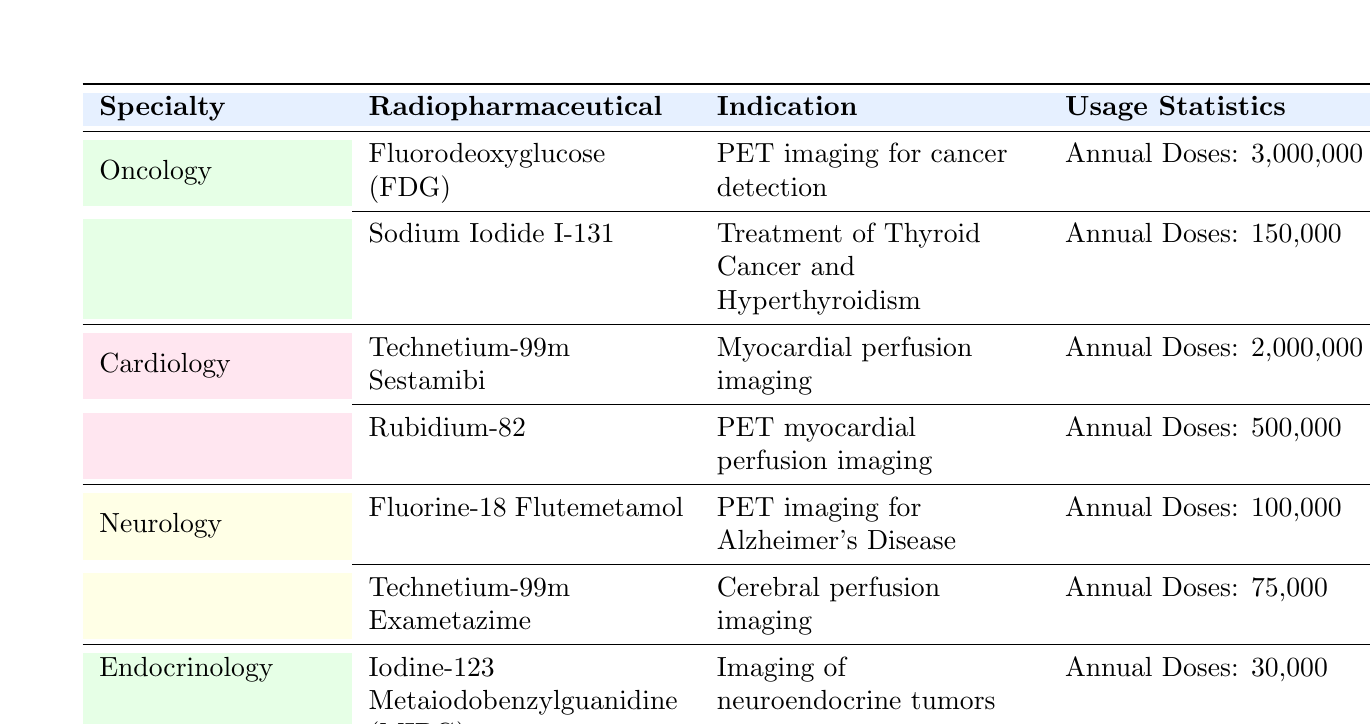What is the annual dose administered for Fluorodeoxyglucose (FDG)? According to the table, the annual doses administered for Fluorodeoxyglucose (FDG) is listed as 3,000,000.
Answer: 3,000,000 What is the main indication for Sodium Iodide I-131? The table states that the main indication for Sodium Iodide I-131 is the treatment of Thyroid Cancer and Hyperthyroidism.
Answer: Treatment of Thyroid Cancer and Hyperthyroidism How many annual doses are administered for Technetium-99m Sestamibi? The table shows that Technetium-99m Sestamibi has 2,000,000 annual doses administered.
Answer: 2,000,000 Which specialty has the lowest annual dose of radiopharmaceuticals administered? From the table, Endocrinology has the lowest annual dose of 30,000, compared to the other specialties with higher values.
Answer: Endocrinology What is the total annual dose administered for all radiation pharmaceuticals listed in Oncology? In Oncology, Fluorodeoxyglucose has 3,000,000 doses and Sodium Iodide I-131 has 150,000 doses. Adding these gives 3,000,000 + 150,000 = 3,150,000.
Answer: 3,150,000 Is it true that Fluorine-18 Flutemetamol is used for imaging in Coronary Artery Disease? The table indicates that Fluorine-18 Flutemetamol has an indication for PET imaging for Alzheimer's Disease, not for Coronary Artery Disease. Thus, the statement is false.
Answer: No How many more doses are administered for Technetium-99m Sestamibi than for Technetium-99m Exametazime? The annual doses for Technetium-99m Sestamibi is 2,000,000 and for Technetium-99m Exametazime is 75,000. The difference is 2,000,000 - 75,000 = 1,925,000.
Answer: 1,925,000 Which common condition is associated with the highest annual doses among the radiopharmaceuticals? Examining the doses, Technetium-99m Sestamibi has the highest annual doses at 2,000,000, which corresponds to conditions like Coronary Artery Disease.
Answer: Coronary Artery Disease What percentage of the total radiopharmaceutical doses in Neurology does Fluorine-18 Flutemetamol represent? In Neurology, Fluorine-18 Flutemetamol has 100,000 doses and Technetium-99m Exametazime has 75,000 doses. The total for Neurology is 100,000 + 75,000 = 175,000. The percentage for Fluorine-18 Flutemetamol is (100,000 / 175,000) * 100 = 57.14%.
Answer: 57.14% 